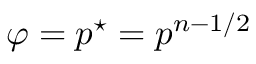<formula> <loc_0><loc_0><loc_500><loc_500>\varphi = p ^ { ^ { * } } = p ^ { n - 1 / 2 }</formula> 